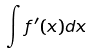<formula> <loc_0><loc_0><loc_500><loc_500>\int f ^ { \prime } ( x ) d x</formula> 